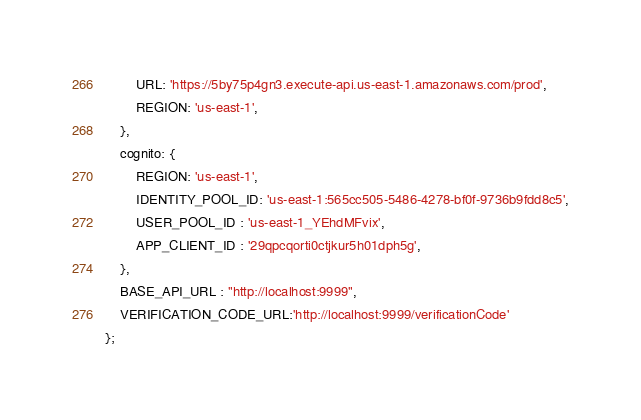<code> <loc_0><loc_0><loc_500><loc_500><_JavaScript_>        URL: 'https://5by75p4gn3.execute-api.us-east-1.amazonaws.com/prod',
        REGION: 'us-east-1',
    },
    cognito: {
        REGION: 'us-east-1',
        IDENTITY_POOL_ID: 'us-east-1:565cc505-5486-4278-bf0f-9736b9fdd8c5',
        USER_POOL_ID : 'us-east-1_YEhdMFvix',
        APP_CLIENT_ID : '29qpcqorti0ctjkur5h01dph5g',
    },
    BASE_API_URL : "http://localhost:9999",
    VERIFICATION_CODE_URL:'http://localhost:9999/verificationCode'
};</code> 